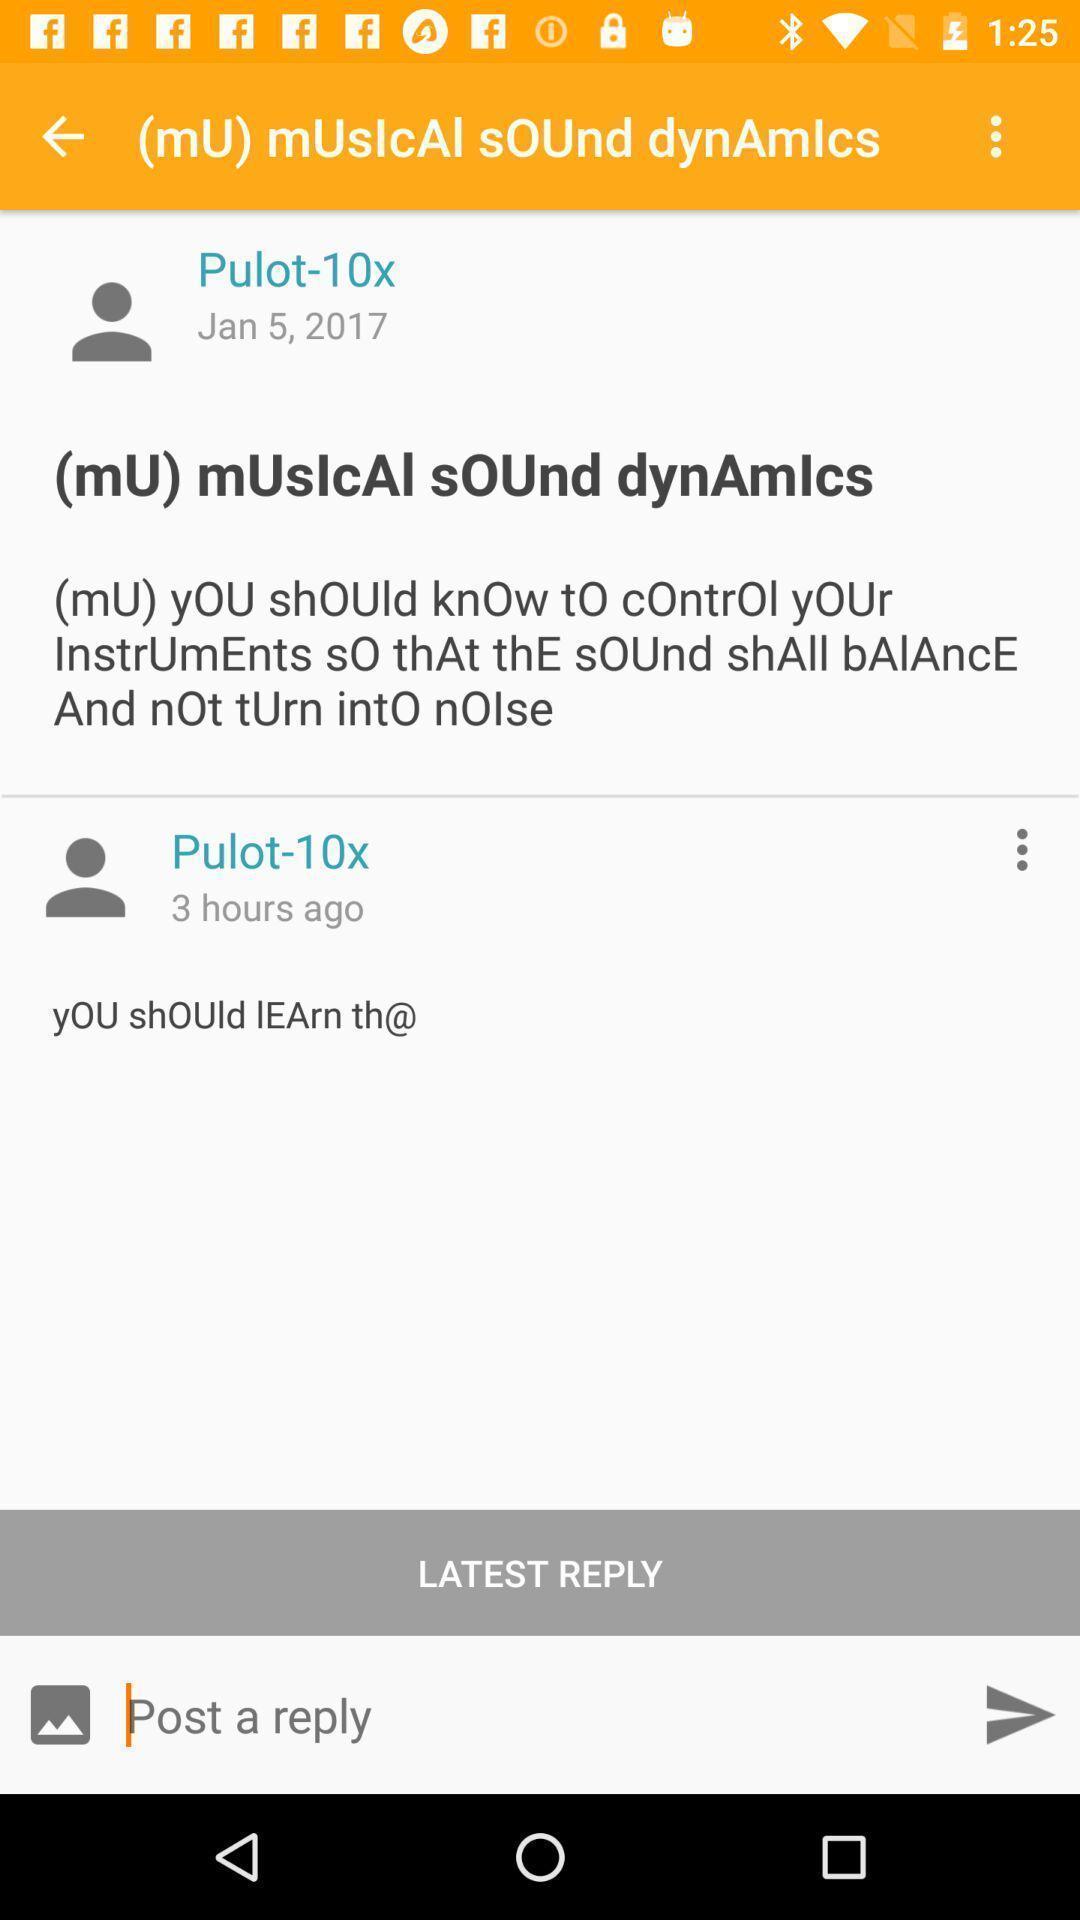Provide a description of this screenshot. Social app page with chat and reply option. 